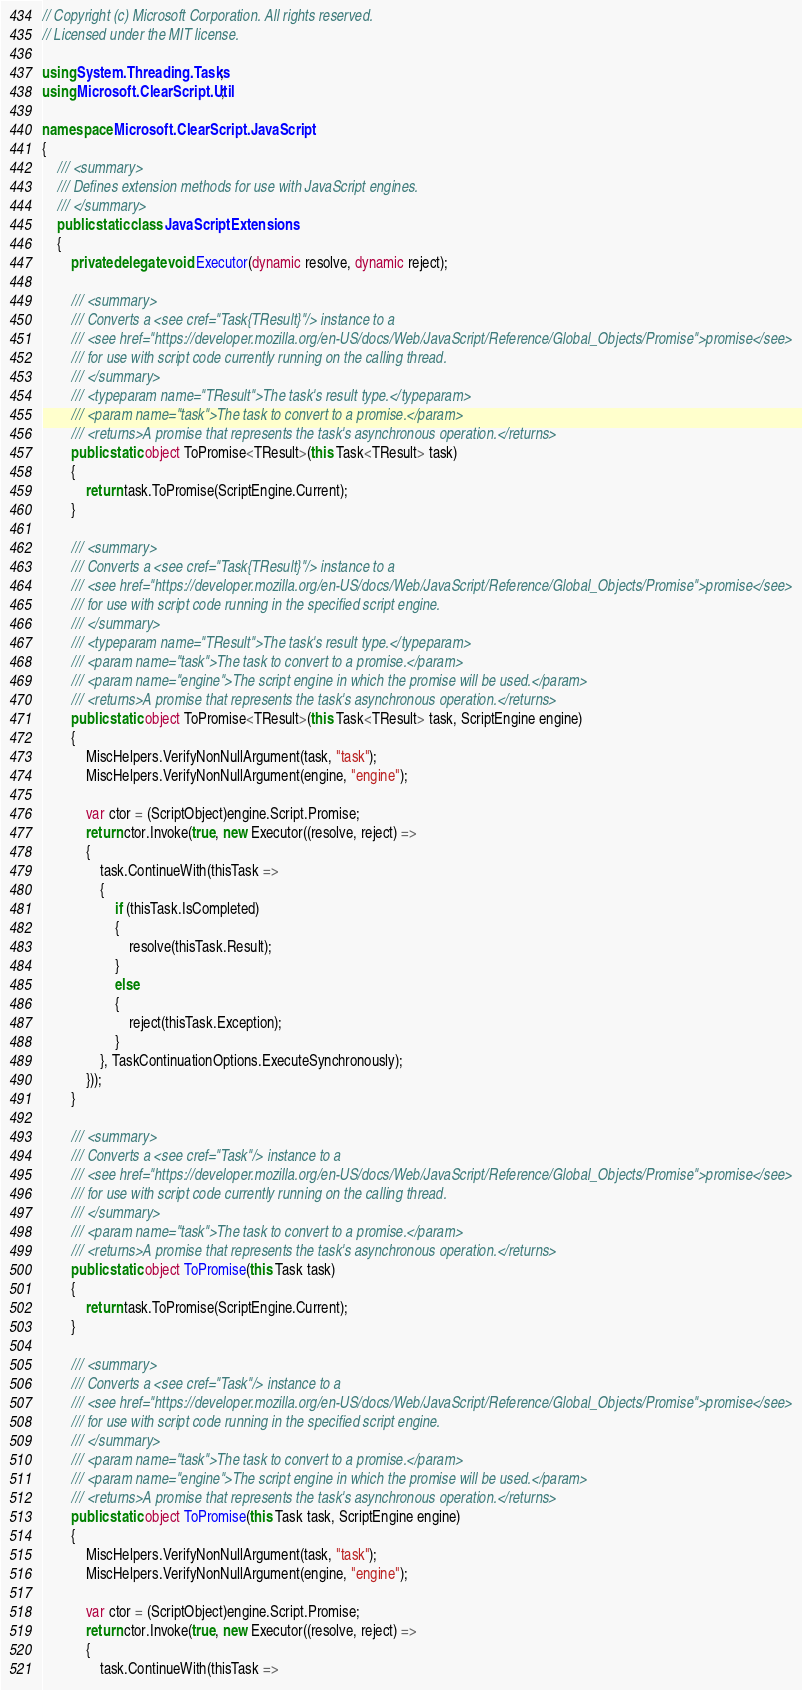<code> <loc_0><loc_0><loc_500><loc_500><_C#_>// Copyright (c) Microsoft Corporation. All rights reserved.
// Licensed under the MIT license.

using System.Threading.Tasks;
using Microsoft.ClearScript.Util;

namespace Microsoft.ClearScript.JavaScript
{
    /// <summary>
    /// Defines extension methods for use with JavaScript engines.
    /// </summary>
    public static class JavaScriptExtensions
    {
        private delegate void Executor(dynamic resolve, dynamic reject);

        /// <summary>
        /// Converts a <see cref="Task{TResult}"/> instance to a
        /// <see href="https://developer.mozilla.org/en-US/docs/Web/JavaScript/Reference/Global_Objects/Promise">promise</see>
        /// for use with script code currently running on the calling thread.
        /// </summary>
        /// <typeparam name="TResult">The task's result type.</typeparam>
        /// <param name="task">The task to convert to a promise.</param>
        /// <returns>A promise that represents the task's asynchronous operation.</returns>
        public static object ToPromise<TResult>(this Task<TResult> task)
        {
            return task.ToPromise(ScriptEngine.Current);
        }

        /// <summary>
        /// Converts a <see cref="Task{TResult}"/> instance to a
        /// <see href="https://developer.mozilla.org/en-US/docs/Web/JavaScript/Reference/Global_Objects/Promise">promise</see>
        /// for use with script code running in the specified script engine.
        /// </summary>
        /// <typeparam name="TResult">The task's result type.</typeparam>
        /// <param name="task">The task to convert to a promise.</param>
        /// <param name="engine">The script engine in which the promise will be used.</param>
        /// <returns>A promise that represents the task's asynchronous operation.</returns>
        public static object ToPromise<TResult>(this Task<TResult> task, ScriptEngine engine)
        {
            MiscHelpers.VerifyNonNullArgument(task, "task");
            MiscHelpers.VerifyNonNullArgument(engine, "engine");

            var ctor = (ScriptObject)engine.Script.Promise;
            return ctor.Invoke(true, new Executor((resolve, reject) =>
            {
                task.ContinueWith(thisTask =>
                {
                    if (thisTask.IsCompleted)
                    {
                        resolve(thisTask.Result);
                    }
                    else
                    {
                        reject(thisTask.Exception);
                    }
                }, TaskContinuationOptions.ExecuteSynchronously);
            }));
        }

        /// <summary>
        /// Converts a <see cref="Task"/> instance to a
        /// <see href="https://developer.mozilla.org/en-US/docs/Web/JavaScript/Reference/Global_Objects/Promise">promise</see>
        /// for use with script code currently running on the calling thread.
        /// </summary>
        /// <param name="task">The task to convert to a promise.</param>
        /// <returns>A promise that represents the task's asynchronous operation.</returns>
        public static object ToPromise(this Task task)
        {
            return task.ToPromise(ScriptEngine.Current);
        }

        /// <summary>
        /// Converts a <see cref="Task"/> instance to a
        /// <see href="https://developer.mozilla.org/en-US/docs/Web/JavaScript/Reference/Global_Objects/Promise">promise</see>
        /// for use with script code running in the specified script engine.
        /// </summary>
        /// <param name="task">The task to convert to a promise.</param>
        /// <param name="engine">The script engine in which the promise will be used.</param>
        /// <returns>A promise that represents the task's asynchronous operation.</returns>
        public static object ToPromise(this Task task, ScriptEngine engine)
        {
            MiscHelpers.VerifyNonNullArgument(task, "task");
            MiscHelpers.VerifyNonNullArgument(engine, "engine");

            var ctor = (ScriptObject)engine.Script.Promise;
            return ctor.Invoke(true, new Executor((resolve, reject) =>
            {
                task.ContinueWith(thisTask =></code> 